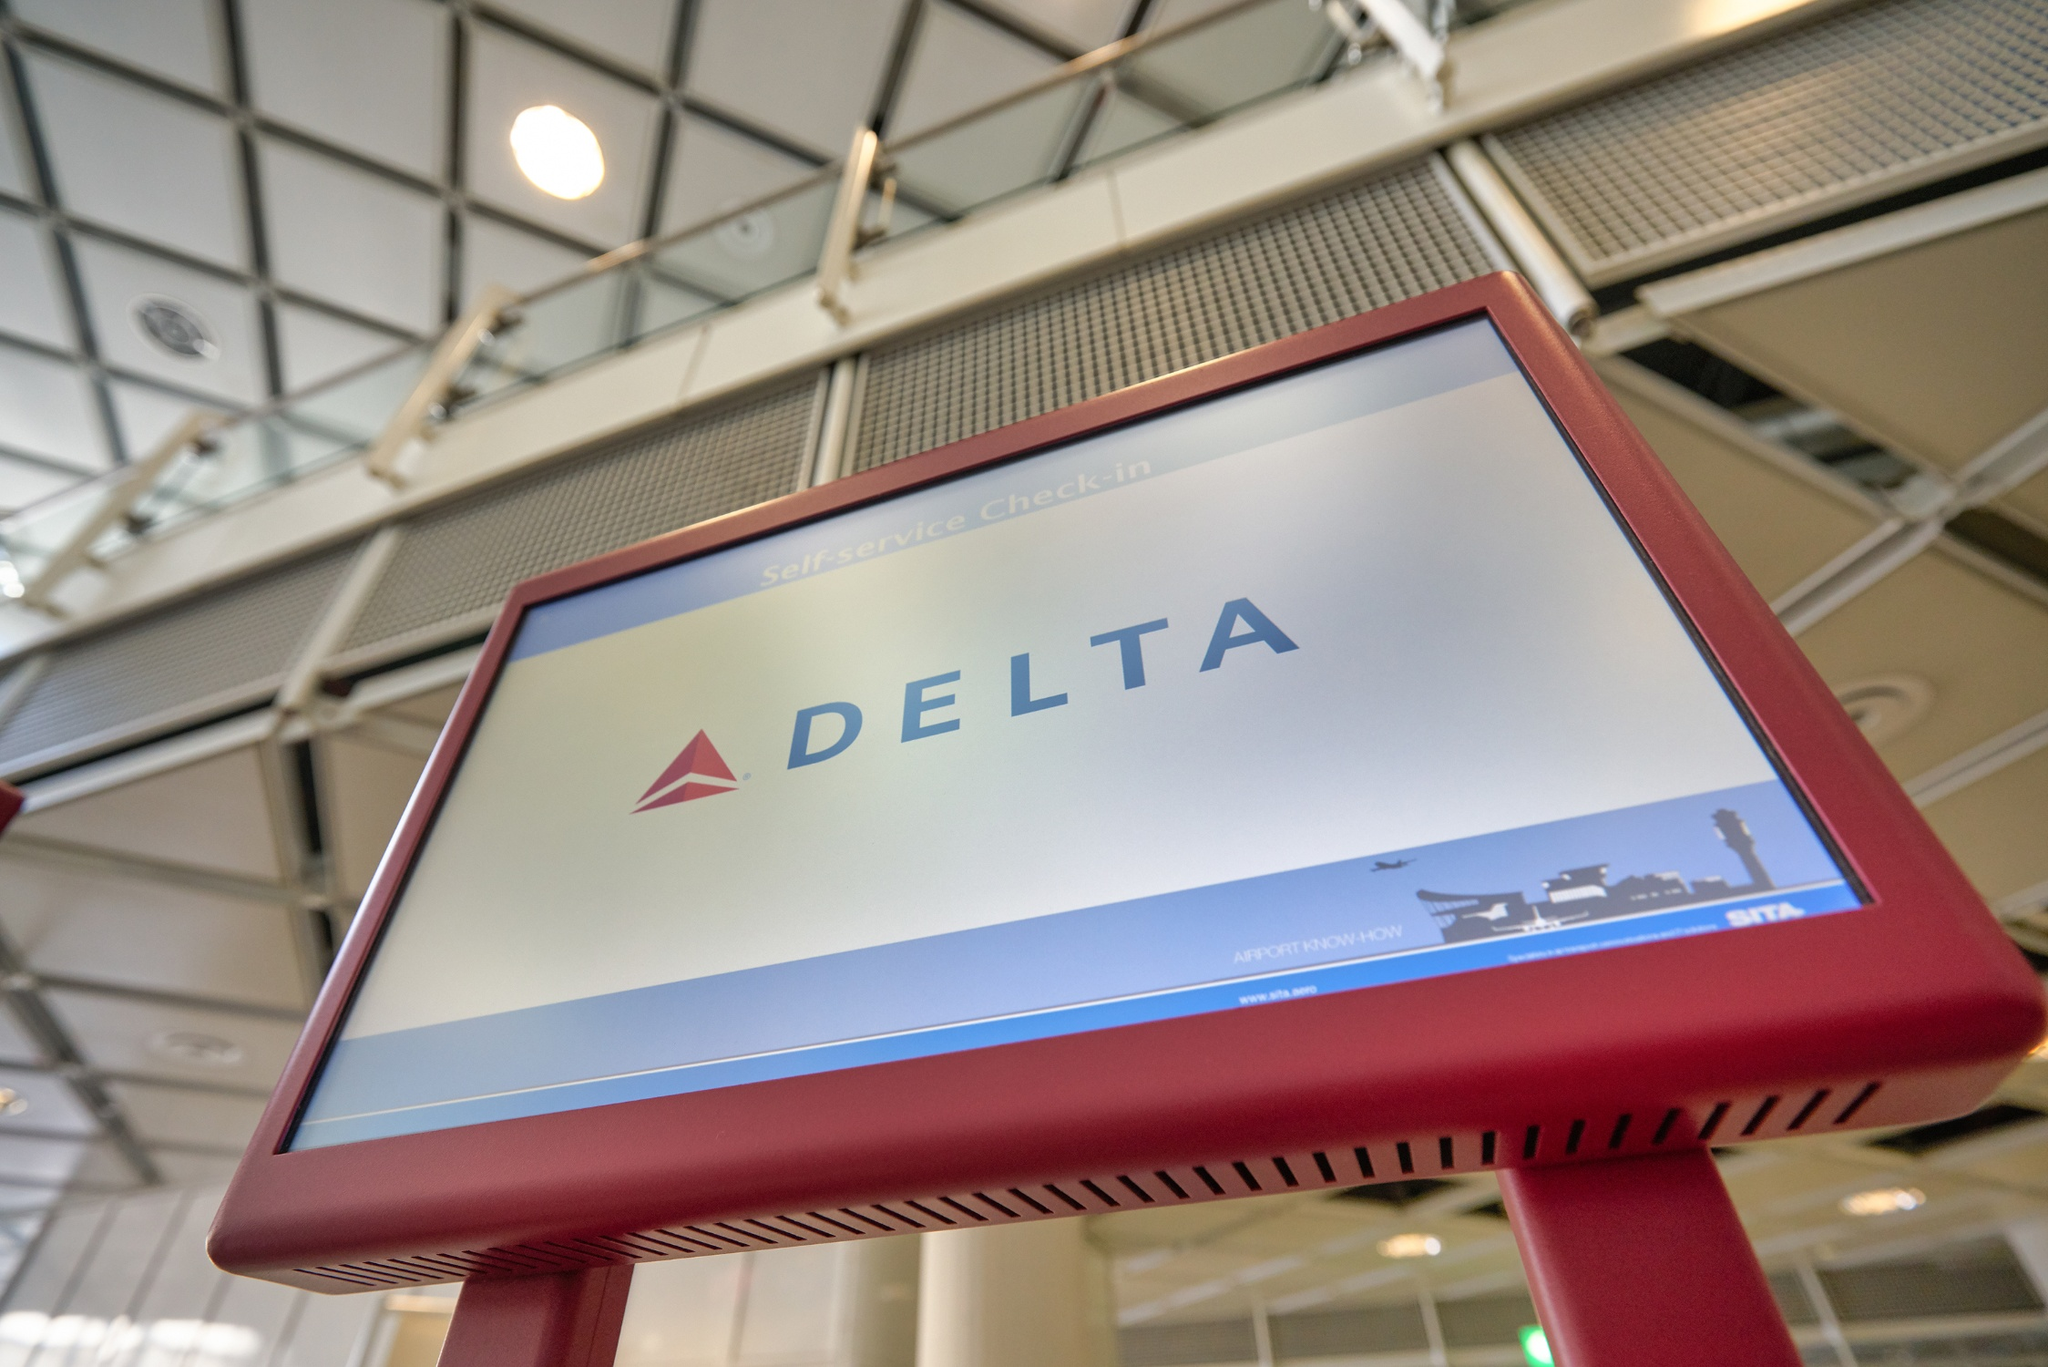How would you describe the overall aesthetic and atmosphere of this airport terminal based on this snapshot? The overall aesthetic of the airport terminal, as seen in the snapshot, is modern and welcoming. The high ceilings and large windows create a bright and airy atmosphere, highlighted by the abundance of natural light. The clean lines and geometric patterns in the architecture, coupled with polished metal railings and glass barriers, emphasize a sleek and contemporary design. This environment seems thoughtfully crafted to make travelers feel comfortable and relaxed as they navigate through the terminal. 